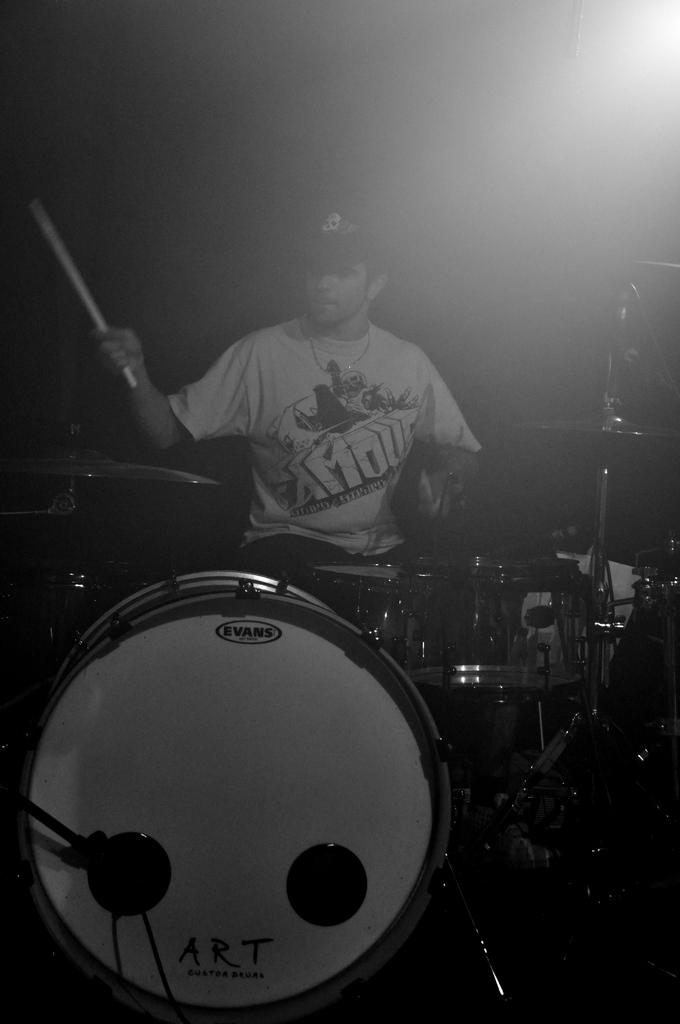What is the main subject of the image? There is a person in the image. What is the person doing in the image? The person is sitting and playing drums. How many chickens are in the person's pocket in the image? There are no chickens present in the image, and the person's pocket is not visible. 